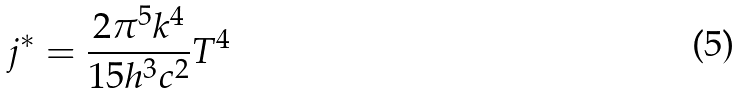<formula> <loc_0><loc_0><loc_500><loc_500>j ^ { * } = \frac { 2 \pi ^ { 5 } k ^ { 4 } } { 1 5 h ^ { 3 } c ^ { 2 } } T ^ { 4 }</formula> 